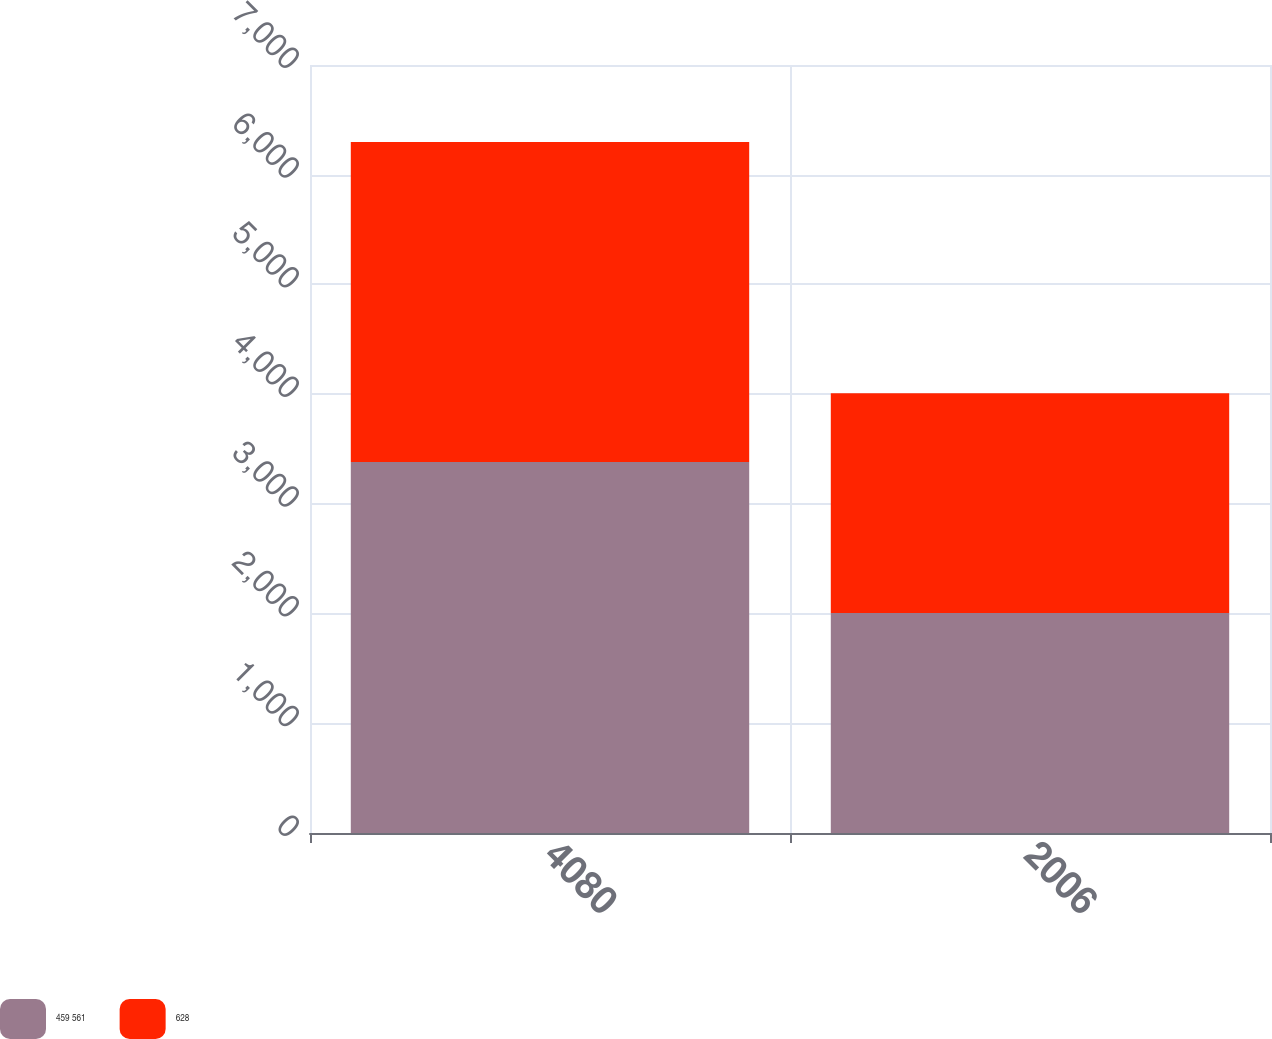<chart> <loc_0><loc_0><loc_500><loc_500><stacked_bar_chart><ecel><fcel>4080<fcel>2006<nl><fcel>459 561<fcel>3382<fcel>2005<nl><fcel>628<fcel>2917<fcel>2004<nl></chart> 